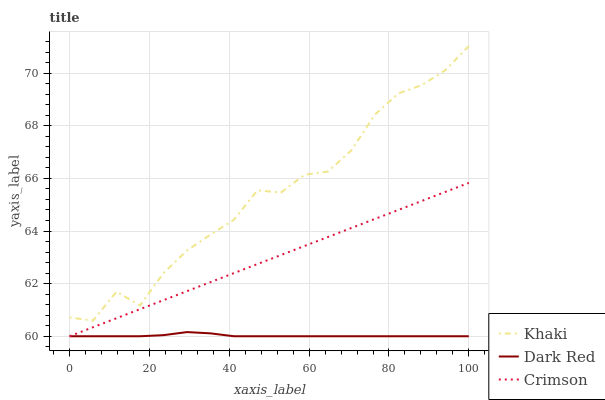Does Khaki have the minimum area under the curve?
Answer yes or no. No. Does Dark Red have the maximum area under the curve?
Answer yes or no. No. Is Dark Red the smoothest?
Answer yes or no. No. Is Dark Red the roughest?
Answer yes or no. No. Does Khaki have the lowest value?
Answer yes or no. No. Does Dark Red have the highest value?
Answer yes or no. No. Is Dark Red less than Khaki?
Answer yes or no. Yes. Is Khaki greater than Crimson?
Answer yes or no. Yes. Does Dark Red intersect Khaki?
Answer yes or no. No. 